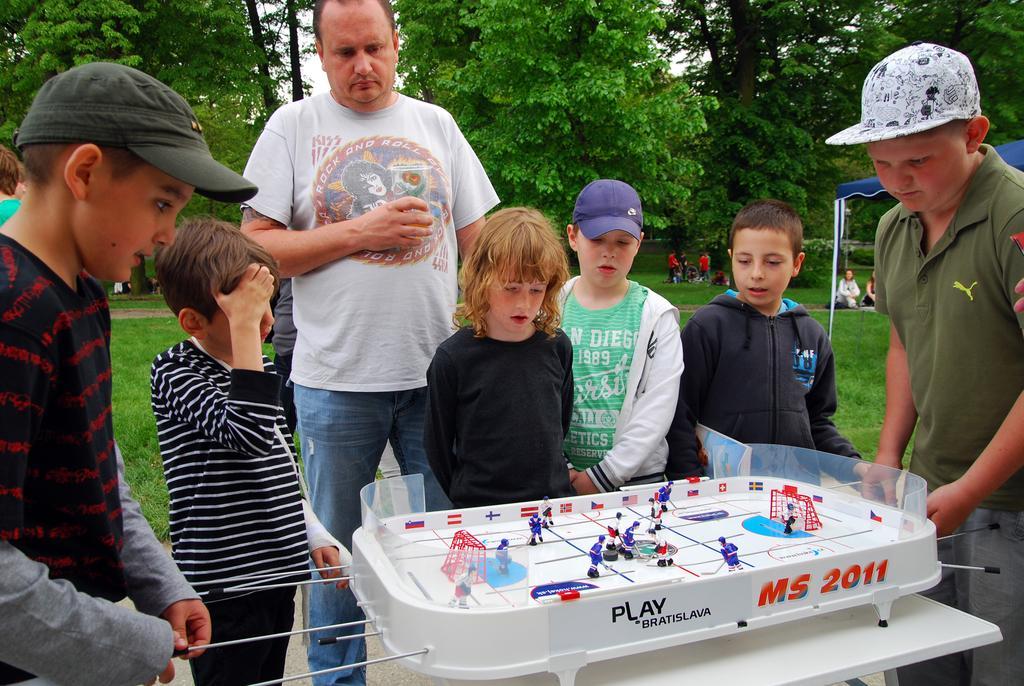How would you summarize this image in a sentence or two? This picture is clicked in a garden. There are few children playing table hockey. Three is tent to the right corner. In the background there are trees, sky and grass on the ground. In the background there are few people. 